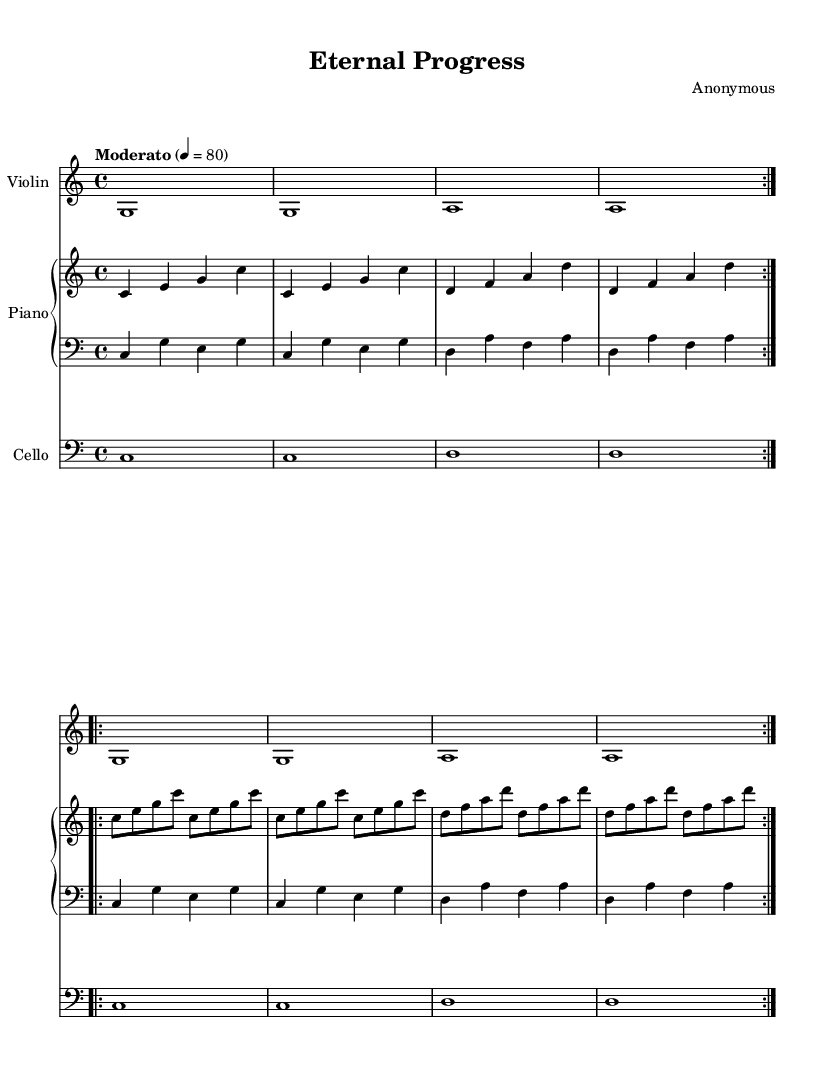What is the key signature of this music? The key signature is determined by the number of sharps or flats at the beginning of the staff. In this case, there are no sharps or flats indicated, which means it is in C major.
Answer: C major What is the time signature of this music? The time signature is found at the beginning of the score, indicated by the fraction. Here, it is written as 4/4, meaning there are four beats in a measure.
Answer: 4/4 What is the tempo marking of this music? The tempo marking is located at the beginning of the score. It indicates the speed at which the piece should be played, and in this case, it is marked as "Moderato" at a quarter note equals 80 beats per minute.
Answer: Moderato How many times is the piano right hand part repeated? The music indicates a repeated section for the right hand of the piano in two parts, each of which is repeated twice. Therefore, we count the indication "volta 2" and conclude that it's played four times total.
Answer: 4 What instrument plays the highest pitches in this piece? The highest pitches are usually provided by the violin, which is indicated on the upper staff. The music shows the violin part with notes that are generally higher in pitch than those for the piano and cello.
Answer: Violin What is the indication for the cellist regarding the clef? The clef for the cello is specifically indicated as the bass clef at the beginning of the cello staff. This tells the player how to read notes lower in pitch, common for the cello range.
Answer: Bass clef How many measures are in the first section of the piano part? By examining the structure of the piano part, we see it is organized into two main repeated sections, where each section (the first and the second) contains four measures, leading to a total of eight measures.
Answer: 8 